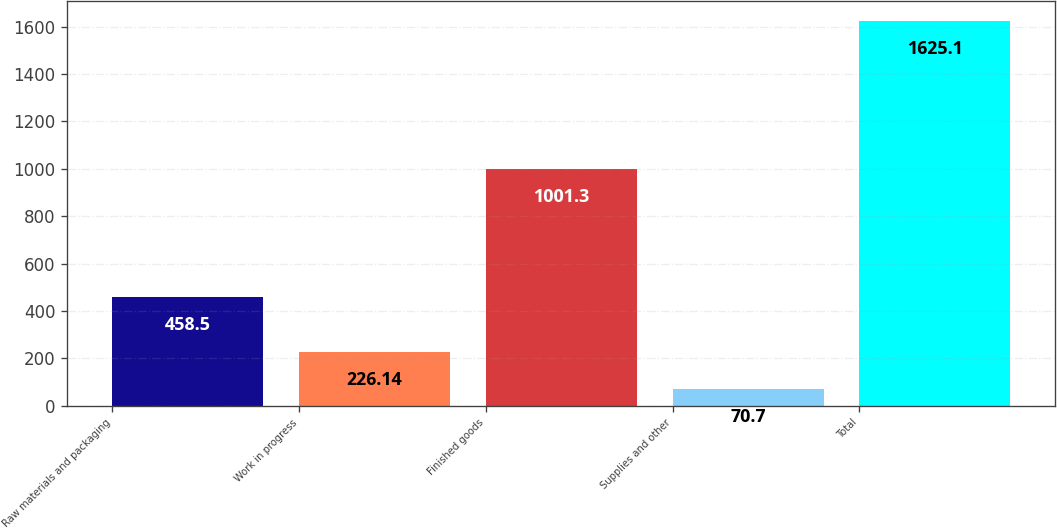Convert chart. <chart><loc_0><loc_0><loc_500><loc_500><bar_chart><fcel>Raw materials and packaging<fcel>Work in progress<fcel>Finished goods<fcel>Supplies and other<fcel>Total<nl><fcel>458.5<fcel>226.14<fcel>1001.3<fcel>70.7<fcel>1625.1<nl></chart> 